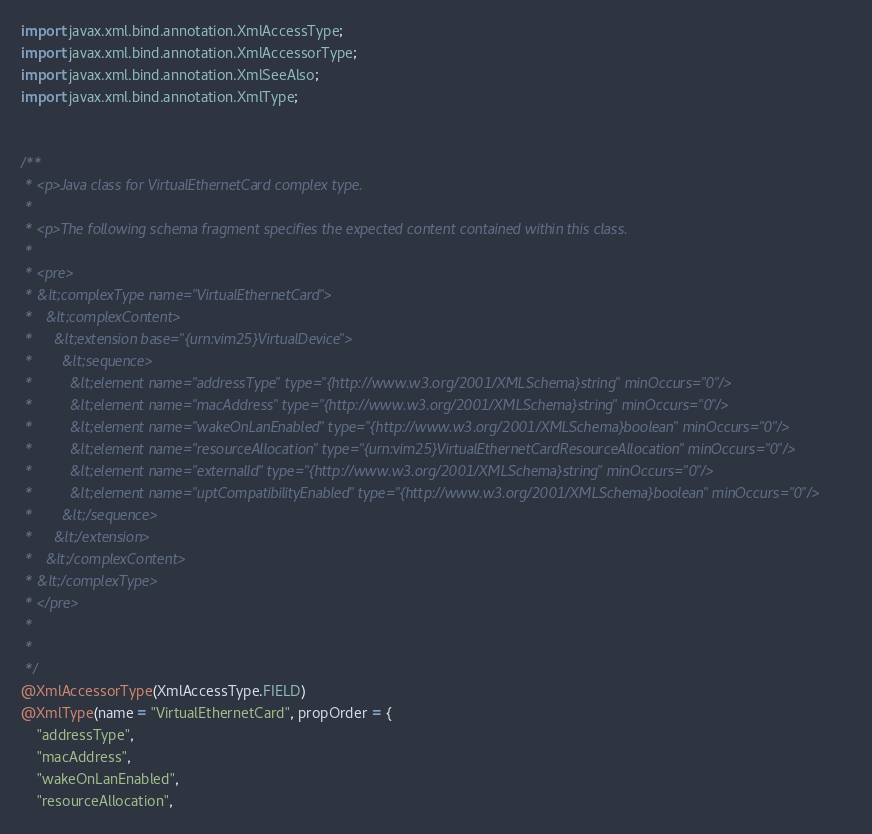<code> <loc_0><loc_0><loc_500><loc_500><_Java_>import javax.xml.bind.annotation.XmlAccessType;
import javax.xml.bind.annotation.XmlAccessorType;
import javax.xml.bind.annotation.XmlSeeAlso;
import javax.xml.bind.annotation.XmlType;


/**
 * <p>Java class for VirtualEthernetCard complex type.
 * 
 * <p>The following schema fragment specifies the expected content contained within this class.
 * 
 * <pre>
 * &lt;complexType name="VirtualEthernetCard">
 *   &lt;complexContent>
 *     &lt;extension base="{urn:vim25}VirtualDevice">
 *       &lt;sequence>
 *         &lt;element name="addressType" type="{http://www.w3.org/2001/XMLSchema}string" minOccurs="0"/>
 *         &lt;element name="macAddress" type="{http://www.w3.org/2001/XMLSchema}string" minOccurs="0"/>
 *         &lt;element name="wakeOnLanEnabled" type="{http://www.w3.org/2001/XMLSchema}boolean" minOccurs="0"/>
 *         &lt;element name="resourceAllocation" type="{urn:vim25}VirtualEthernetCardResourceAllocation" minOccurs="0"/>
 *         &lt;element name="externalId" type="{http://www.w3.org/2001/XMLSchema}string" minOccurs="0"/>
 *         &lt;element name="uptCompatibilityEnabled" type="{http://www.w3.org/2001/XMLSchema}boolean" minOccurs="0"/>
 *       &lt;/sequence>
 *     &lt;/extension>
 *   &lt;/complexContent>
 * &lt;/complexType>
 * </pre>
 * 
 * 
 */
@XmlAccessorType(XmlAccessType.FIELD)
@XmlType(name = "VirtualEthernetCard", propOrder = {
    "addressType",
    "macAddress",
    "wakeOnLanEnabled",
    "resourceAllocation",</code> 